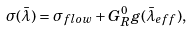<formula> <loc_0><loc_0><loc_500><loc_500>\sigma ( \bar { \lambda } ) = \sigma _ { f l o w } + G _ { R } ^ { 0 } g ( \bar { \lambda } _ { e f f } ) ,</formula> 